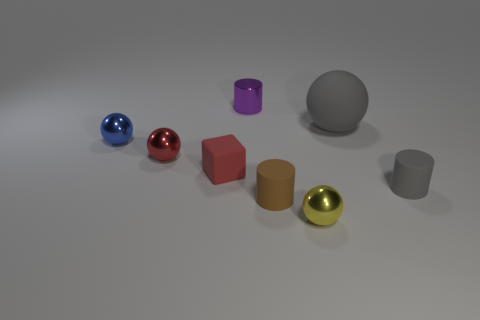There is a small rubber thing that is both to the left of the small gray object and on the right side of the purple object; what is its shape?
Offer a terse response. Cylinder. What material is the ball that is in front of the small blue shiny sphere and behind the brown matte object?
Ensure brevity in your answer.  Metal. What shape is the brown object that is the same material as the tiny cube?
Your answer should be compact. Cylinder. Is there any other thing that is the same color as the small metallic cylinder?
Your response must be concise. No. Are there more tiny red objects in front of the small red ball than small red metallic blocks?
Keep it short and to the point. Yes. What is the brown cylinder made of?
Your answer should be compact. Rubber. How many shiny balls have the same size as the blue thing?
Ensure brevity in your answer.  2. Is the number of brown cylinders that are in front of the yellow shiny sphere the same as the number of tiny rubber things in front of the tiny red shiny ball?
Ensure brevity in your answer.  No. Are the tiny brown cylinder and the tiny gray thing made of the same material?
Your answer should be very brief. Yes. Is there a ball that is behind the tiny matte cylinder behind the brown rubber thing?
Your answer should be compact. Yes. 